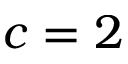Convert formula to latex. <formula><loc_0><loc_0><loc_500><loc_500>c = 2</formula> 